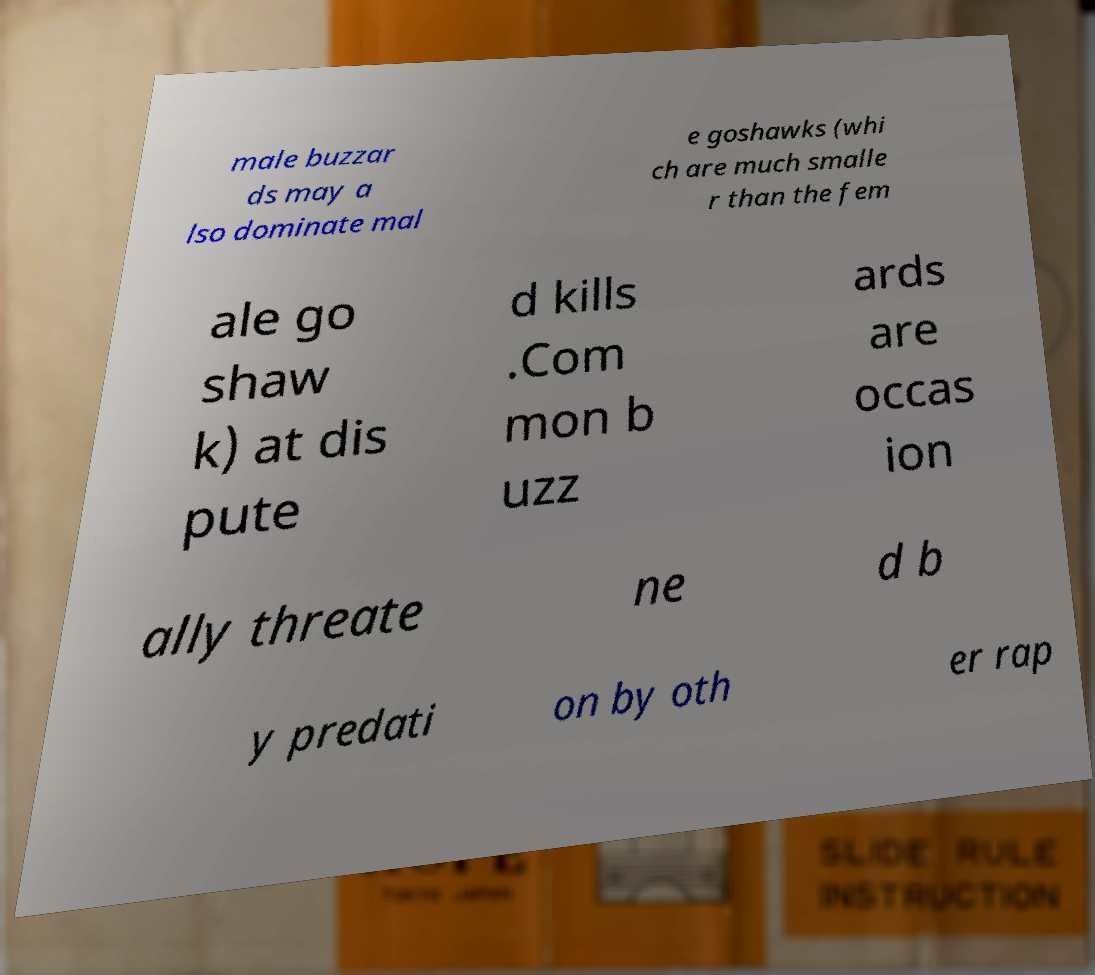Please read and relay the text visible in this image. What does it say? male buzzar ds may a lso dominate mal e goshawks (whi ch are much smalle r than the fem ale go shaw k) at dis pute d kills .Com mon b uzz ards are occas ion ally threate ne d b y predati on by oth er rap 